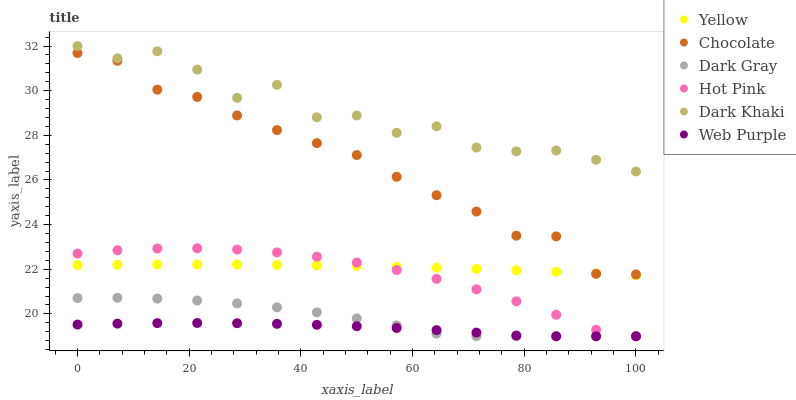Does Web Purple have the minimum area under the curve?
Answer yes or no. Yes. Does Dark Khaki have the maximum area under the curve?
Answer yes or no. Yes. Does Hot Pink have the minimum area under the curve?
Answer yes or no. No. Does Hot Pink have the maximum area under the curve?
Answer yes or no. No. Is Yellow the smoothest?
Answer yes or no. Yes. Is Dark Khaki the roughest?
Answer yes or no. Yes. Is Hot Pink the smoothest?
Answer yes or no. No. Is Hot Pink the roughest?
Answer yes or no. No. Does Hot Pink have the lowest value?
Answer yes or no. Yes. Does Yellow have the lowest value?
Answer yes or no. No. Does Dark Khaki have the highest value?
Answer yes or no. Yes. Does Hot Pink have the highest value?
Answer yes or no. No. Is Web Purple less than Chocolate?
Answer yes or no. Yes. Is Dark Khaki greater than Chocolate?
Answer yes or no. Yes. Does Chocolate intersect Yellow?
Answer yes or no. Yes. Is Chocolate less than Yellow?
Answer yes or no. No. Is Chocolate greater than Yellow?
Answer yes or no. No. Does Web Purple intersect Chocolate?
Answer yes or no. No. 